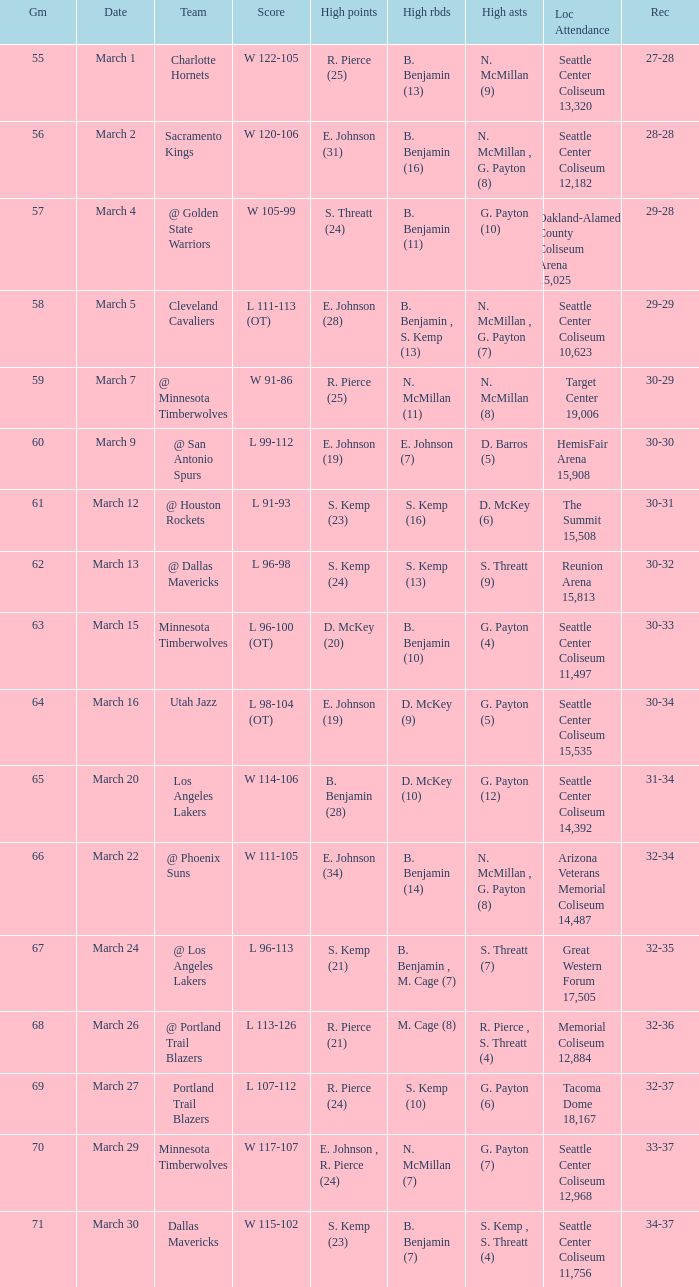Which game was played on march 2? 56.0. 